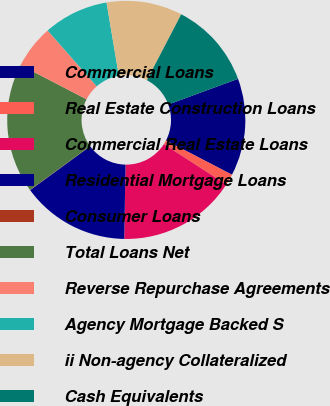<chart> <loc_0><loc_0><loc_500><loc_500><pie_chart><fcel>Commercial Loans<fcel>Real Estate Construction Loans<fcel>Commercial Real Estate Loans<fcel>Residential Mortgage Loans<fcel>Consumer Loans<fcel>Total Loans Net<fcel>Reverse Repurchase Agreements<fcel>Agency Mortgage Backed S<fcel>ii Non-agency Collateralized<fcel>Cash Equivalents<nl><fcel>13.22%<fcel>1.51%<fcel>16.15%<fcel>14.69%<fcel>0.04%<fcel>17.62%<fcel>5.9%<fcel>8.83%<fcel>10.29%<fcel>11.76%<nl></chart> 